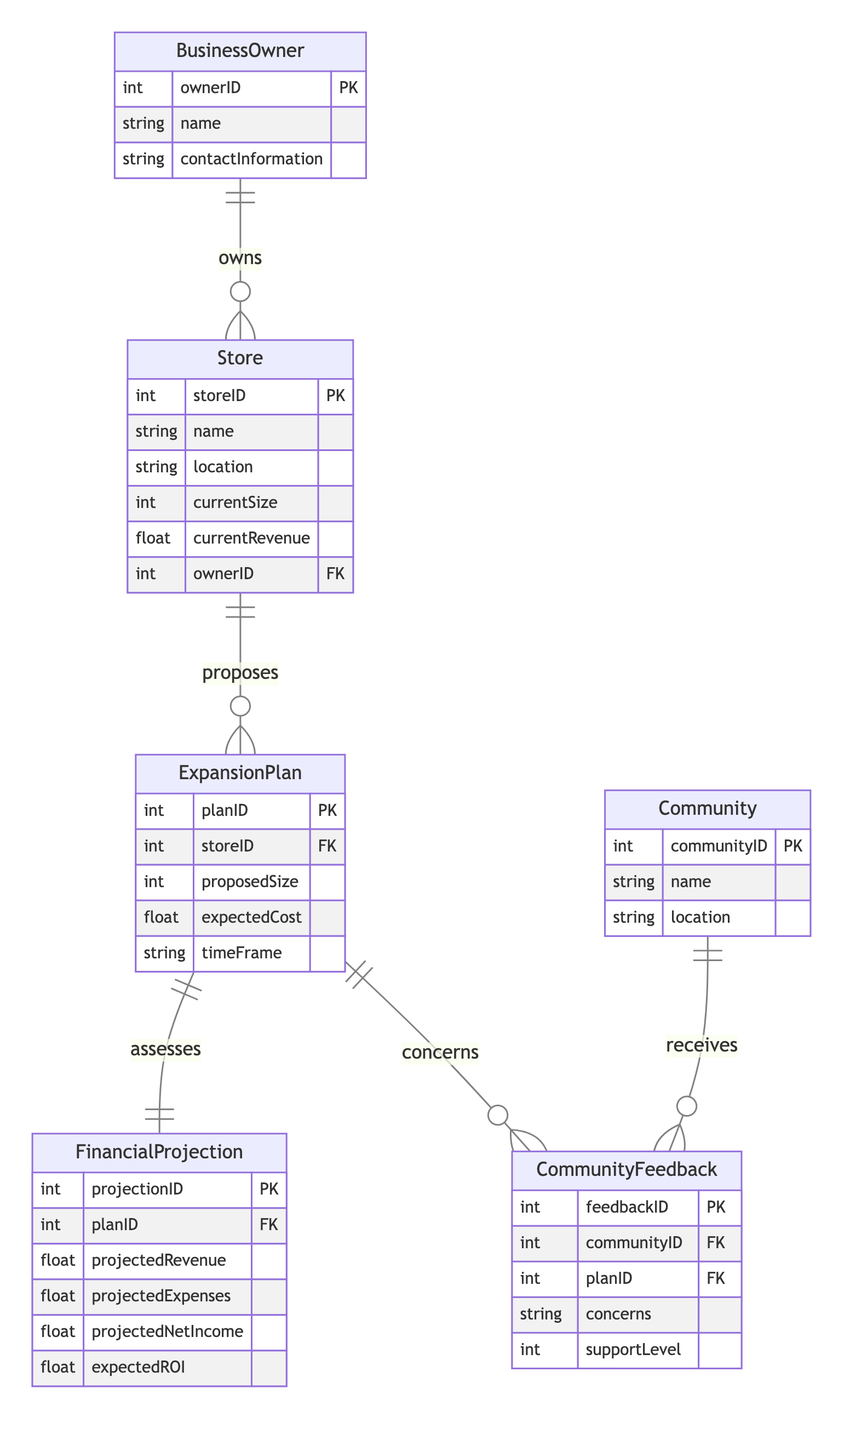What entity represents the owner of the store? The "BusinessOwner" entity represents the owner of the store in the diagram. It is indicated by the relationship "owns" between the BusinessOwner and Store entities.
Answer: BusinessOwner How many entities are in the diagram? The diagram contains a total of six entities: BusinessOwner, Store, ExpansionPlan, FinancialProjection, Community, and CommunityFeedback. Counting each of these gives us six.
Answer: 6 What is the foreign key in the FinancialProjection entity? The foreign key in the FinancialProjection entity is "planID," which links it to the ExpansionPlan entity, indicating which projection corresponds to which plan.
Answer: planID What is the relationship between Community and CommunityFeedback? The relationship between Community and CommunityFeedback is that Community receives CommunityFeedback, indicated by a "1 to many" relationship, meaning one community can have many feedback entries.
Answer: receives What is the primary key in the Store entity? The primary key in the Store entity is "storeID," which uniquely identifies each store in the database.
Answer: storeID What type of feedback does the ExpansionPlan receive from the Community? The ExpansionPlan receives feedback represented in the CommunityFeedback entity, detailing concerns and support levels from different communities about the plan.
Answer: concerns How many support levels can feedback have related to the ExpansionPlan? The support level expressed in the CommunityFeedback entity can vary, but logically, it can range from complete opposition to full support based on community sentiment, suggesting an integer range.
Answer: integer Which entity assesses the financial projections for a specific expansion plan? The "ExpansionPlan" entity is assessed by the "FinancialProjection" entity to evaluate its financial impact, shown by the "assesses" relationship.
Answer: FinancialProjection What attribute links the Store to the ExpansionPlan? The attribute that links the Store to the ExpansionPlan is "storeID," which serves as a foreign key, allowing the ExpansionPlan to reference the specific store it pertains to.
Answer: storeID 